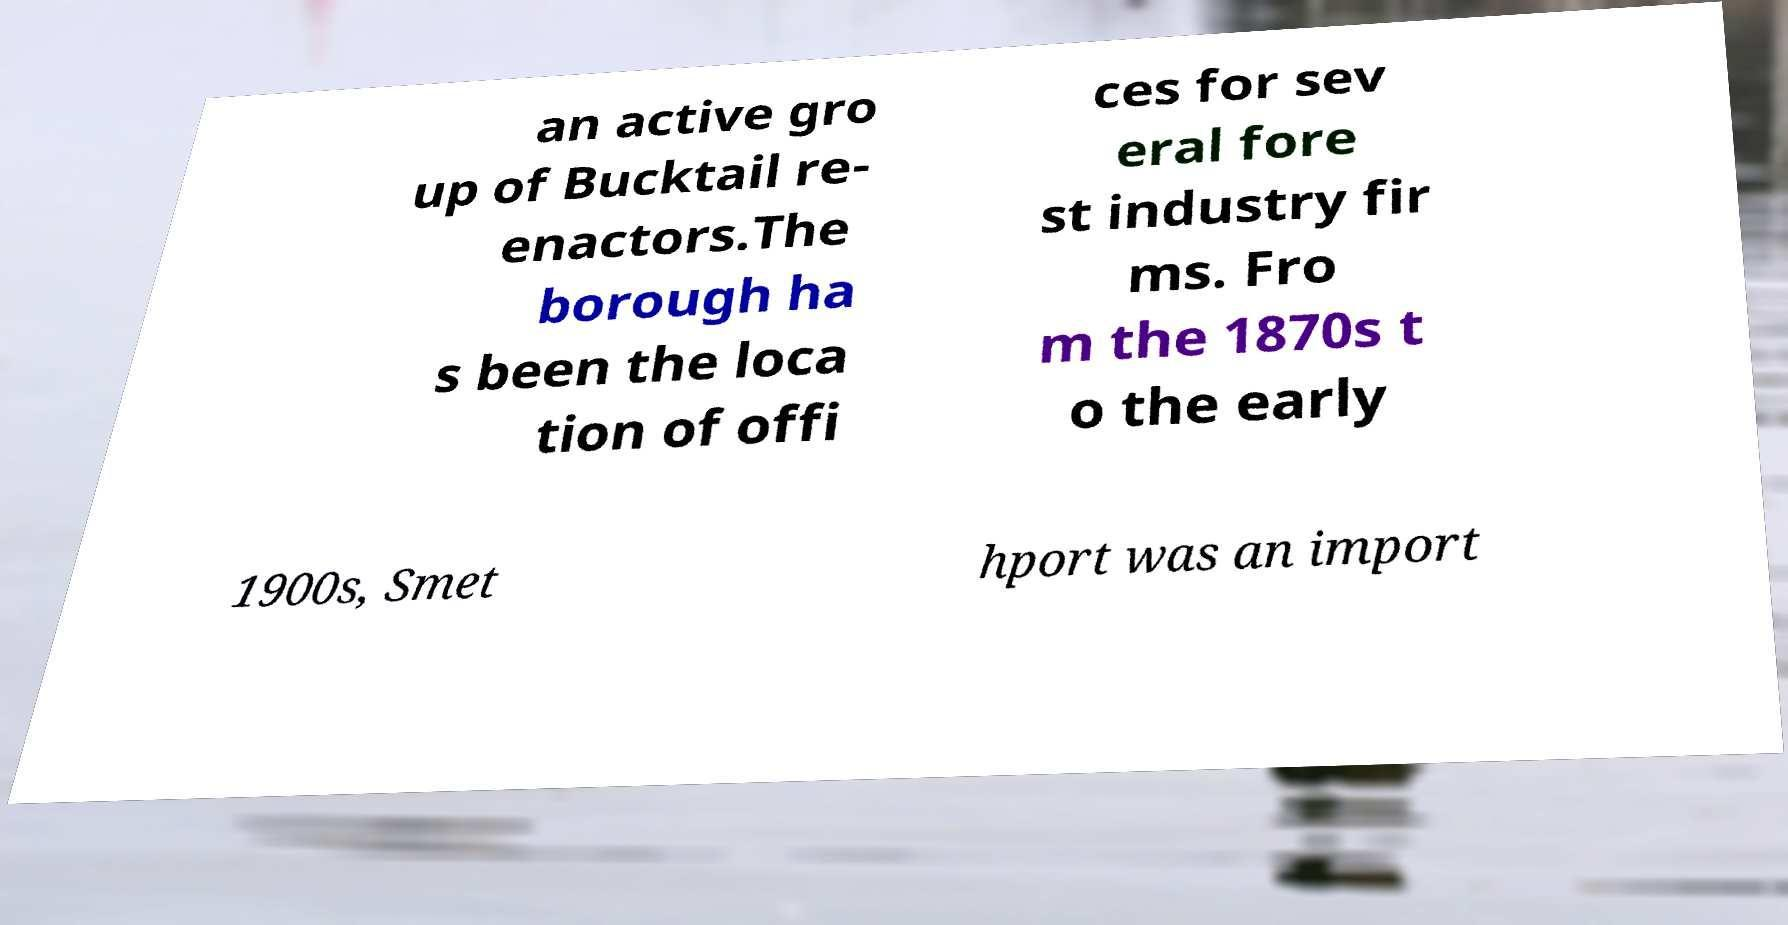For documentation purposes, I need the text within this image transcribed. Could you provide that? an active gro up of Bucktail re- enactors.The borough ha s been the loca tion of offi ces for sev eral fore st industry fir ms. Fro m the 1870s t o the early 1900s, Smet hport was an import 